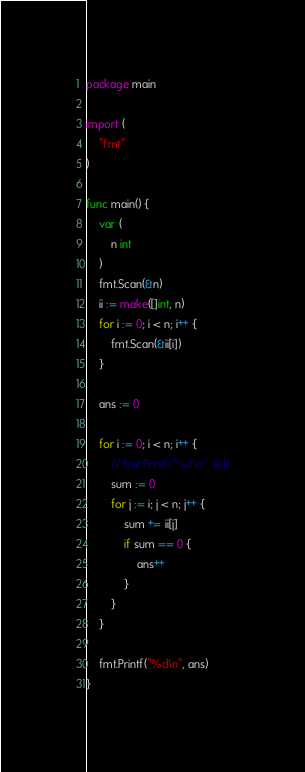Convert code to text. <code><loc_0><loc_0><loc_500><loc_500><_Go_>package main

import (
	"fmt"
)

func main() {
	var (
		n int
	)
	fmt.Scan(&n)
	ii := make([]int, n)
	for i := 0; i < n; i++ {
		fmt.Scan(&ii[i])
	}

	ans := 0

	for i := 0; i < n; i++ {
		// fmt.Printf("%d\n", ii[i])
		sum := 0
		for j := i; j < n; j++ {
			sum += ii[j]
			if sum == 0 {
				ans++
			}
		}
	}

	fmt.Printf("%d\n", ans)
}
</code> 